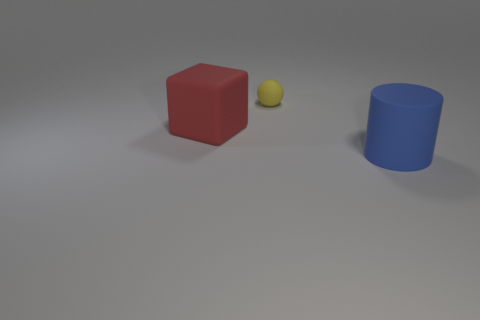Add 1 yellow spheres. How many objects exist? 4 Subtract all cylinders. How many objects are left? 2 Subtract all blue cylinders. Subtract all tiny spheres. How many objects are left? 1 Add 1 big blue matte objects. How many big blue matte objects are left? 2 Add 1 tiny green rubber objects. How many tiny green rubber objects exist? 1 Subtract 0 purple balls. How many objects are left? 3 